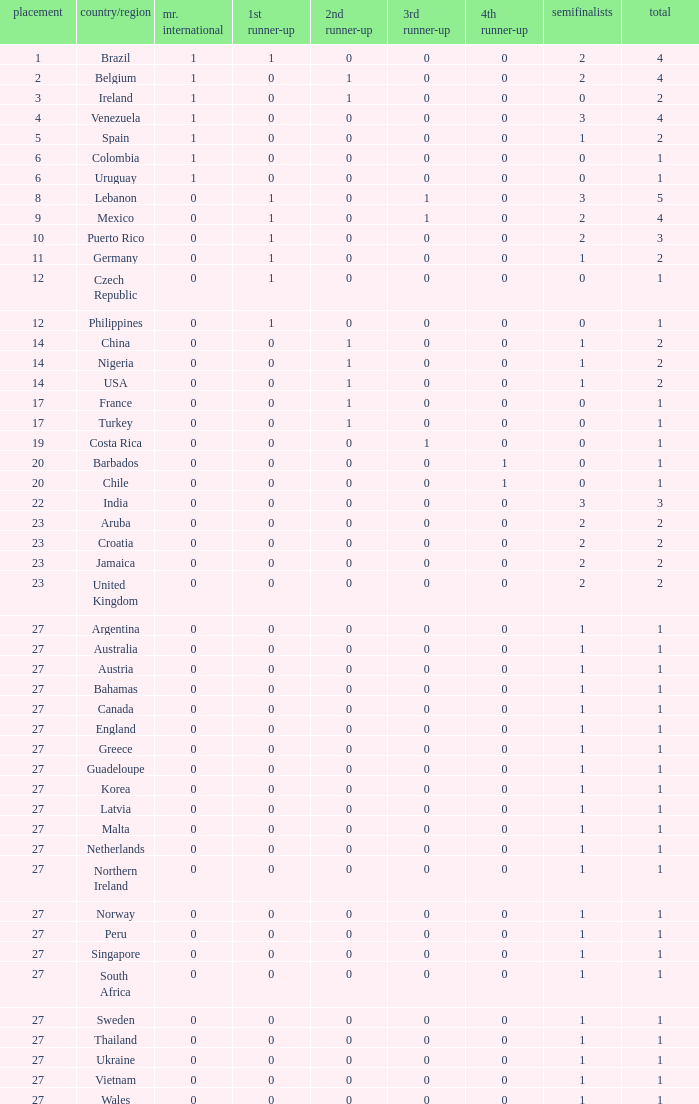What is the number of 1st runner up values for Jamaica? 1.0. 